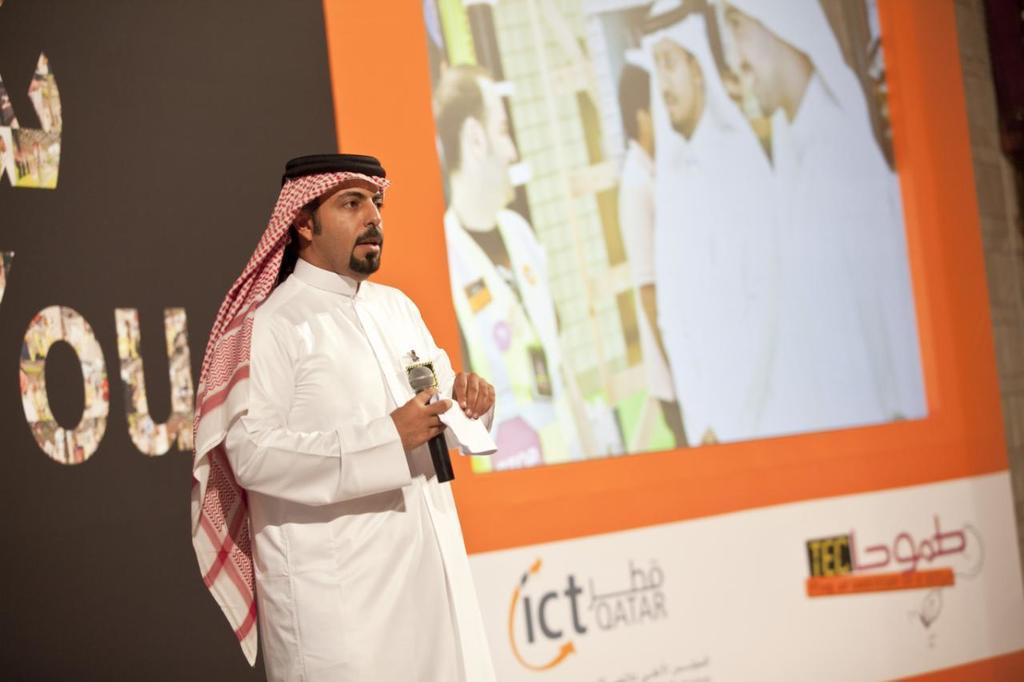What is the main subject of the image? There is a man in the image. What is the man doing in the image? The man is standing in the image. What object is the man holding in the image? The man is holding a microphone in the image. What can be seen in the background of the image? There are two posters in the background of the image. What type of linen is being offered by the man in the image? There is no linen present in the image, nor is the man offering anything. 